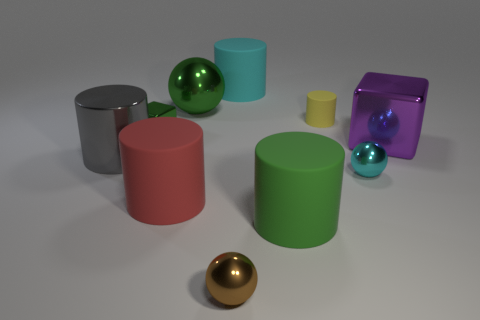There is a matte object that is the same color as the tiny metal block; what shape is it?
Ensure brevity in your answer.  Cylinder. What is the large thing that is right of the tiny brown shiny ball and in front of the big gray metallic cylinder made of?
Provide a succinct answer. Rubber. What is the shape of the large thing to the right of the yellow rubber cylinder?
Make the answer very short. Cube. What is the shape of the cyan object that is on the left side of the green object in front of the large cube?
Provide a short and direct response. Cylinder. Are there any other big metallic things of the same shape as the big purple metal object?
Provide a short and direct response. No. What shape is the red object that is the same size as the gray metal object?
Provide a short and direct response. Cylinder. There is a large green thing that is in front of the sphere that is behind the big gray thing; are there any balls on the right side of it?
Provide a short and direct response. Yes. Are there any green shiny spheres of the same size as the yellow thing?
Keep it short and to the point. No. There is a brown ball left of the large cube; what size is it?
Keep it short and to the point. Small. What color is the small ball in front of the matte object that is left of the big cylinder that is behind the big shiny cylinder?
Provide a succinct answer. Brown. 